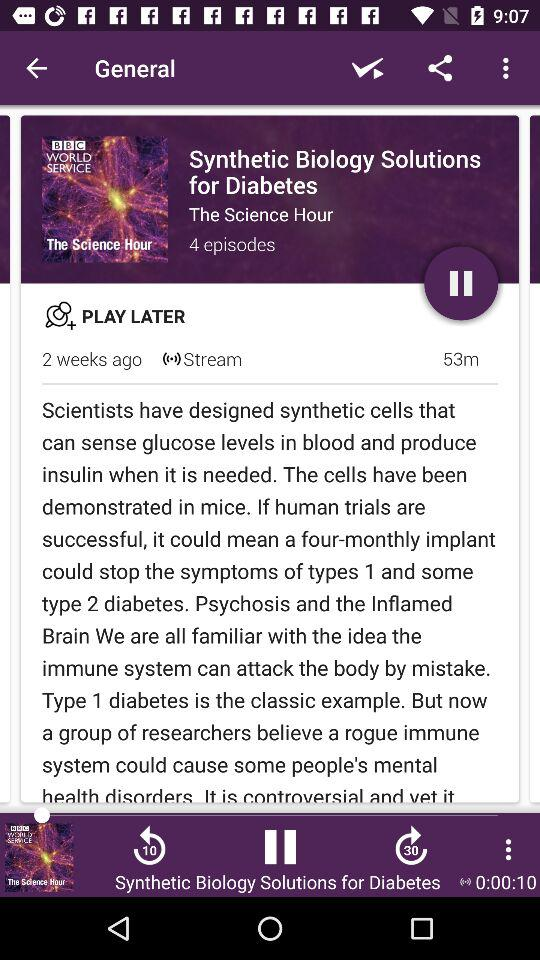What topics are covered in the episodes of this series? The series covers various innovative approaches in synthetic biology to manage and potentially cure diabetes, including the design of synthetic cells that can monitor and respond to glucose levels in the human body. 